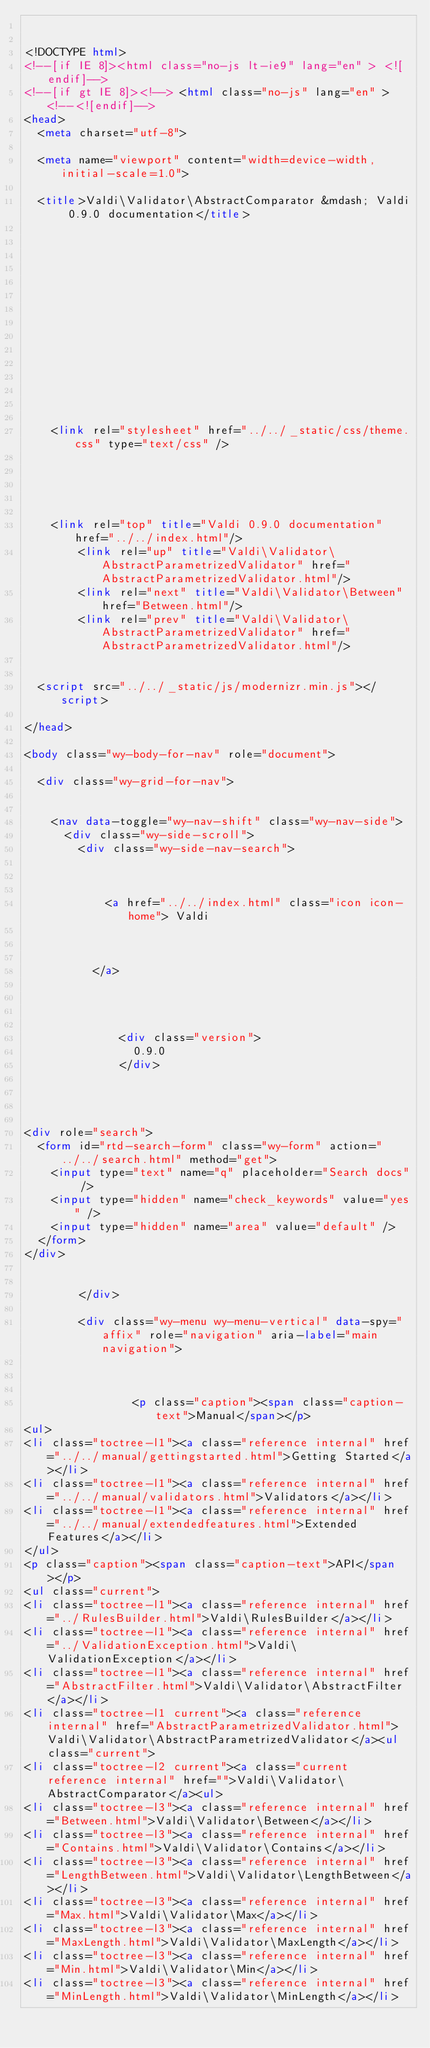Convert code to text. <code><loc_0><loc_0><loc_500><loc_500><_HTML_>

<!DOCTYPE html>
<!--[if IE 8]><html class="no-js lt-ie9" lang="en" > <![endif]-->
<!--[if gt IE 8]><!--> <html class="no-js" lang="en" > <!--<![endif]-->
<head>
  <meta charset="utf-8">
  
  <meta name="viewport" content="width=device-width, initial-scale=1.0">
  
  <title>Valdi\Validator\AbstractComparator &mdash; Valdi 0.9.0 documentation</title>
  

  
  

  

  
  
    

  

  
  
    <link rel="stylesheet" href="../../_static/css/theme.css" type="text/css" />
  

  

  
    <link rel="top" title="Valdi 0.9.0 documentation" href="../../index.html"/>
        <link rel="up" title="Valdi\Validator\AbstractParametrizedValidator" href="AbstractParametrizedValidator.html"/>
        <link rel="next" title="Valdi\Validator\Between" href="Between.html"/>
        <link rel="prev" title="Valdi\Validator\AbstractParametrizedValidator" href="AbstractParametrizedValidator.html"/> 

  
  <script src="../../_static/js/modernizr.min.js"></script>

</head>

<body class="wy-body-for-nav" role="document">

  <div class="wy-grid-for-nav">

    
    <nav data-toggle="wy-nav-shift" class="wy-nav-side">
      <div class="wy-side-scroll">
        <div class="wy-side-nav-search">
          

          
            <a href="../../index.html" class="icon icon-home"> Valdi
          

          
          </a>

          
            
            
              <div class="version">
                0.9.0
              </div>
            
          

          
<div role="search">
  <form id="rtd-search-form" class="wy-form" action="../../search.html" method="get">
    <input type="text" name="q" placeholder="Search docs" />
    <input type="hidden" name="check_keywords" value="yes" />
    <input type="hidden" name="area" value="default" />
  </form>
</div>

          
        </div>

        <div class="wy-menu wy-menu-vertical" data-spy="affix" role="navigation" aria-label="main navigation">
          
            
            
                <p class="caption"><span class="caption-text">Manual</span></p>
<ul>
<li class="toctree-l1"><a class="reference internal" href="../../manual/gettingstarted.html">Getting Started</a></li>
<li class="toctree-l1"><a class="reference internal" href="../../manual/validators.html">Validators</a></li>
<li class="toctree-l1"><a class="reference internal" href="../../manual/extendedfeatures.html">Extended Features</a></li>
</ul>
<p class="caption"><span class="caption-text">API</span></p>
<ul class="current">
<li class="toctree-l1"><a class="reference internal" href="../RulesBuilder.html">Valdi\RulesBuilder</a></li>
<li class="toctree-l1"><a class="reference internal" href="../ValidationException.html">Valdi\ValidationException</a></li>
<li class="toctree-l1"><a class="reference internal" href="AbstractFilter.html">Valdi\Validator\AbstractFilter</a></li>
<li class="toctree-l1 current"><a class="reference internal" href="AbstractParametrizedValidator.html">Valdi\Validator\AbstractParametrizedValidator</a><ul class="current">
<li class="toctree-l2 current"><a class="current reference internal" href="">Valdi\Validator\AbstractComparator</a><ul>
<li class="toctree-l3"><a class="reference internal" href="Between.html">Valdi\Validator\Between</a></li>
<li class="toctree-l3"><a class="reference internal" href="Contains.html">Valdi\Validator\Contains</a></li>
<li class="toctree-l3"><a class="reference internal" href="LengthBetween.html">Valdi\Validator\LengthBetween</a></li>
<li class="toctree-l3"><a class="reference internal" href="Max.html">Valdi\Validator\Max</a></li>
<li class="toctree-l3"><a class="reference internal" href="MaxLength.html">Valdi\Validator\MaxLength</a></li>
<li class="toctree-l3"><a class="reference internal" href="Min.html">Valdi\Validator\Min</a></li>
<li class="toctree-l3"><a class="reference internal" href="MinLength.html">Valdi\Validator\MinLength</a></li></code> 